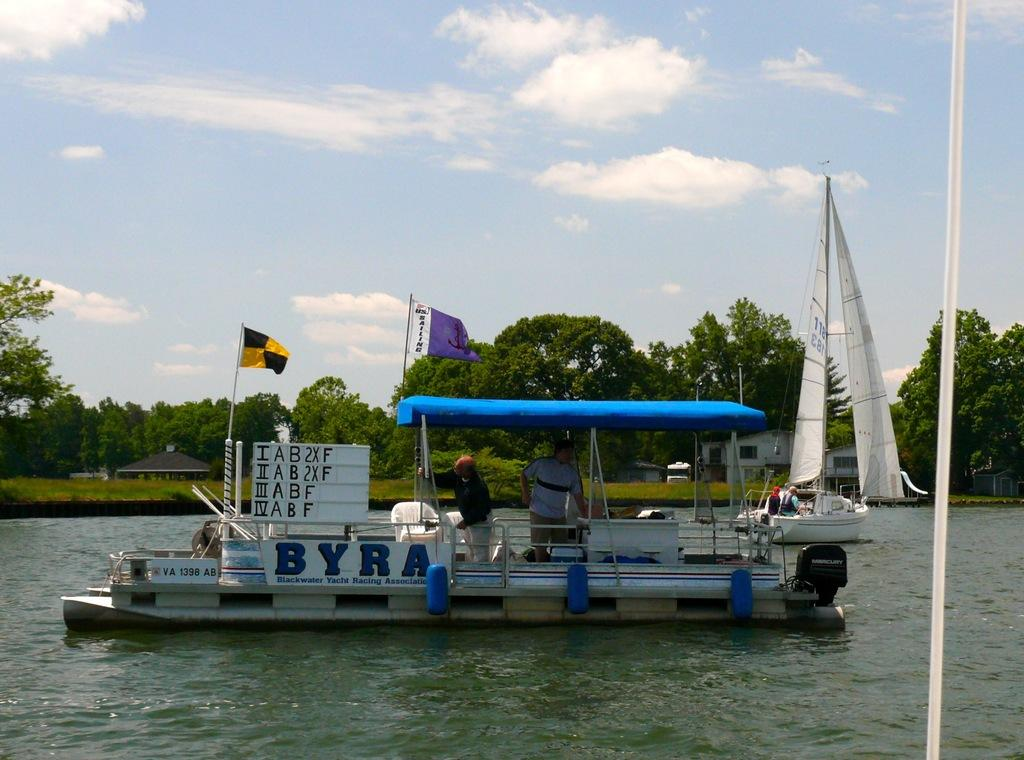<image>
Summarize the visual content of the image. A boat in the water has the letter b on a sign on it. 